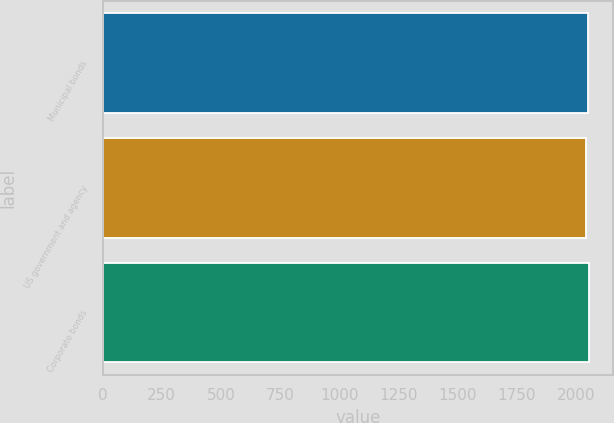Convert chart. <chart><loc_0><loc_0><loc_500><loc_500><bar_chart><fcel>Municipal bonds<fcel>US government and agency<fcel>Corporate bonds<nl><fcel>2051<fcel>2044<fcel>2054<nl></chart> 